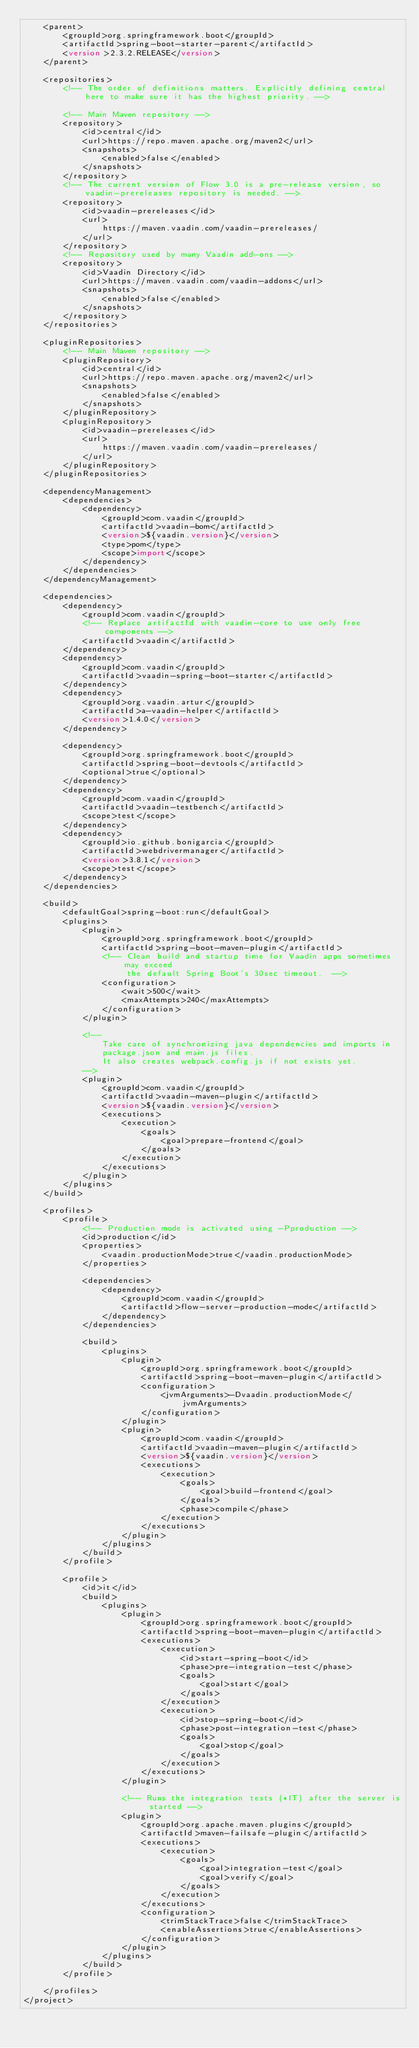<code> <loc_0><loc_0><loc_500><loc_500><_XML_>    <parent>
        <groupId>org.springframework.boot</groupId>
        <artifactId>spring-boot-starter-parent</artifactId>
        <version>2.3.2.RELEASE</version>
    </parent>

    <repositories>
        <!-- The order of definitions matters. Explicitly defining central here to make sure it has the highest priority. -->

        <!-- Main Maven repository -->
        <repository>
            <id>central</id>
            <url>https://repo.maven.apache.org/maven2</url>
            <snapshots>
                <enabled>false</enabled>
            </snapshots>
        </repository>
        <!-- The current version of Flow 3.0 is a pre-release version, so vaadin-prereleases repository is needed. -->
        <repository>
            <id>vaadin-prereleases</id>
            <url>
                https://maven.vaadin.com/vaadin-prereleases/
            </url>
        </repository>
        <!-- Repository used by many Vaadin add-ons -->
        <repository>
            <id>Vaadin Directory</id>
            <url>https://maven.vaadin.com/vaadin-addons</url>
            <snapshots>
                <enabled>false</enabled>
            </snapshots>
        </repository>
    </repositories>

    <pluginRepositories>
        <!-- Main Maven repository -->
        <pluginRepository>
            <id>central</id>
            <url>https://repo.maven.apache.org/maven2</url>
            <snapshots>
                <enabled>false</enabled>
            </snapshots>
        </pluginRepository>
        <pluginRepository>
            <id>vaadin-prereleases</id>
            <url>
                https://maven.vaadin.com/vaadin-prereleases/
            </url>
        </pluginRepository>
    </pluginRepositories>

    <dependencyManagement>
        <dependencies>
            <dependency>
                <groupId>com.vaadin</groupId>
                <artifactId>vaadin-bom</artifactId>
                <version>${vaadin.version}</version>
                <type>pom</type>
                <scope>import</scope>
            </dependency>
        </dependencies>
    </dependencyManagement>

    <dependencies>
        <dependency>
            <groupId>com.vaadin</groupId>
            <!-- Replace artifactId with vaadin-core to use only free components -->
            <artifactId>vaadin</artifactId>
        </dependency>
        <dependency>
            <groupId>com.vaadin</groupId>
            <artifactId>vaadin-spring-boot-starter</artifactId>
        </dependency>
        <dependency>
            <groupId>org.vaadin.artur</groupId>
            <artifactId>a-vaadin-helper</artifactId>
            <version>1.4.0</version>
        </dependency>

        <dependency>
            <groupId>org.springframework.boot</groupId>
            <artifactId>spring-boot-devtools</artifactId>
            <optional>true</optional>
        </dependency>
        <dependency>
            <groupId>com.vaadin</groupId>
            <artifactId>vaadin-testbench</artifactId>
            <scope>test</scope>
        </dependency>
        <dependency>
            <groupId>io.github.bonigarcia</groupId>
            <artifactId>webdrivermanager</artifactId>
            <version>3.8.1</version>
            <scope>test</scope>
        </dependency>
    </dependencies>

    <build>
        <defaultGoal>spring-boot:run</defaultGoal>
        <plugins>
            <plugin>
                <groupId>org.springframework.boot</groupId>
                <artifactId>spring-boot-maven-plugin</artifactId>
                <!-- Clean build and startup time for Vaadin apps sometimes may exceed
                     the default Spring Boot's 30sec timeout.  -->
                <configuration>
                    <wait>500</wait>
                    <maxAttempts>240</maxAttempts>
                </configuration>
            </plugin>

            <!--
                Take care of synchronizing java dependencies and imports in
                package.json and main.js files.
                It also creates webpack.config.js if not exists yet.
            -->
            <plugin>
                <groupId>com.vaadin</groupId>
                <artifactId>vaadin-maven-plugin</artifactId>
                <version>${vaadin.version}</version>
                <executions>
                    <execution>
                        <goals>
                            <goal>prepare-frontend</goal>
                        </goals>
                    </execution>
                </executions>
            </plugin>
        </plugins>
    </build>

    <profiles>
        <profile>
            <!-- Production mode is activated using -Pproduction -->
            <id>production</id>
            <properties>
                <vaadin.productionMode>true</vaadin.productionMode>
            </properties>

            <dependencies>
                <dependency>
                    <groupId>com.vaadin</groupId>
                    <artifactId>flow-server-production-mode</artifactId>
                </dependency>
            </dependencies>

            <build>
                <plugins>
                    <plugin>
                        <groupId>org.springframework.boot</groupId>
                        <artifactId>spring-boot-maven-plugin</artifactId>
                        <configuration>
                            <jvmArguments>-Dvaadin.productionMode</jvmArguments>
                        </configuration>
                    </plugin>
                    <plugin>
                        <groupId>com.vaadin</groupId>
                        <artifactId>vaadin-maven-plugin</artifactId>
                        <version>${vaadin.version}</version>
                        <executions>
                            <execution>
                                <goals>
                                    <goal>build-frontend</goal>
                                </goals>
                                <phase>compile</phase>
                            </execution>
                        </executions>
                    </plugin>
                </plugins>
            </build>
        </profile>

        <profile>
            <id>it</id>
            <build>
                <plugins>
                    <plugin>
                        <groupId>org.springframework.boot</groupId>
                        <artifactId>spring-boot-maven-plugin</artifactId>
                        <executions>
                            <execution>
                                <id>start-spring-boot</id>
                                <phase>pre-integration-test</phase>
                                <goals>
                                    <goal>start</goal>
                                </goals>
                            </execution>
                            <execution>
                                <id>stop-spring-boot</id>
                                <phase>post-integration-test</phase>
                                <goals>
                                    <goal>stop</goal>
                                </goals>
                            </execution>
                        </executions>
                    </plugin>

                    <!-- Runs the integration tests (*IT) after the server is started -->
                    <plugin>
                        <groupId>org.apache.maven.plugins</groupId>
                        <artifactId>maven-failsafe-plugin</artifactId>
                        <executions>
                            <execution>
                                <goals>
                                    <goal>integration-test</goal>
                                    <goal>verify</goal>
                                </goals>
                            </execution>
                        </executions>
                        <configuration>
                            <trimStackTrace>false</trimStackTrace>
                            <enableAssertions>true</enableAssertions>
                        </configuration>
                    </plugin>
                </plugins>
            </build>
        </profile>

    </profiles>
</project></code> 